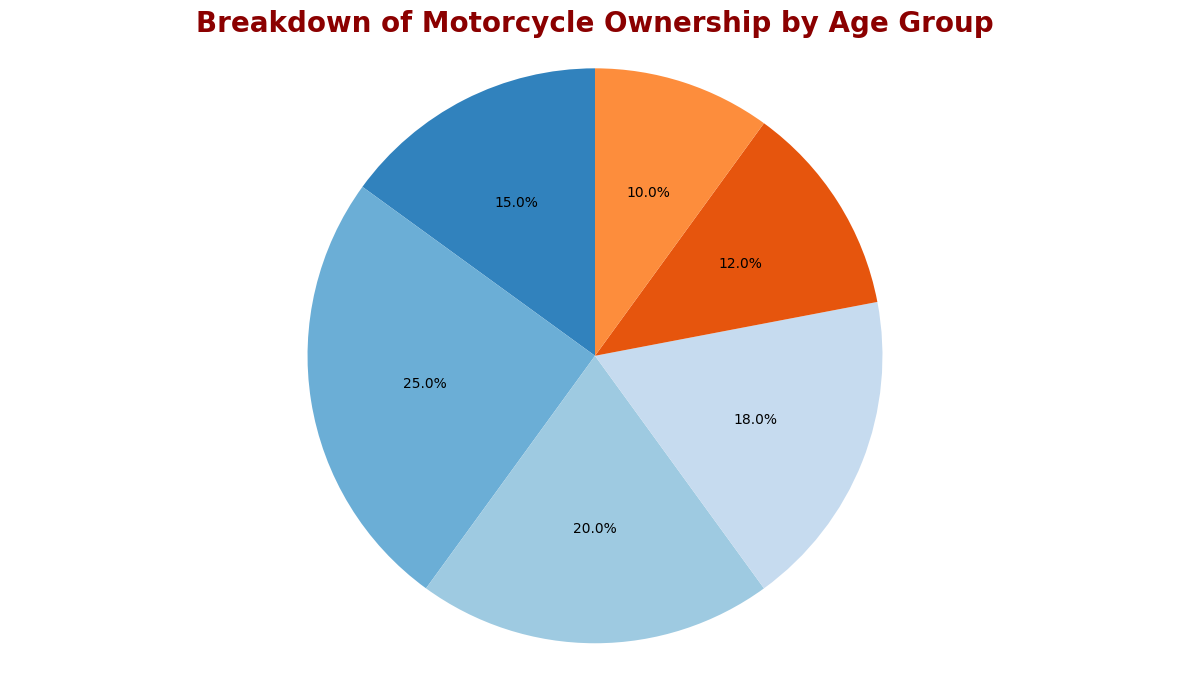Which age group has the highest percentage of motorcycle ownership? The figure shows that the 25-34 age group has the highest percentage of ownership at 25%.
Answer: 25-34 How much larger is the percentage of motorcycle ownership in the 25-34 age group compared to the 65+ age group? The 25-34 age group has 25% ownership and the 65+ age group has 10% ownership. The difference is calculated as 25%-10% = 15%.
Answer: 15% What is the combined percentage of motorcycle ownership for age groups 35-44 and 45-54? The percentage for the 35-44 age group is 20% and for the 45-54 age group is 18%. Adding them together results in 20% + 18% = 38%.
Answer: 38% Which age group has a slightly higher percentage of motorcycle ownership: 35-44 or 45-54? The figure shows that the 35-44 age group has 20% ownership, while the 45-54 age group has 18% ownership. 20% is slightly larger than 18%.
Answer: 35-44 What is the average percentage of motorcycle ownership for the three age groups with the lowest percentages? The age groups with the lowest percentages are 55-64 (12%), 65+ (10%), and 16-24 (15%). The average is calculated as (12% + 10% + 15%) / 3 = 12.33%.
Answer: 12.33% What fraction of the pie chart is represented by the 16-24 age group? The 16-24 age group represents 15% out of a total of 100%. Thus, the fraction is 15/100 = 3/20.
Answer: 3/20 Comparing 16-24 and 25-34 age groups, by what factor is the ownership percentage in the 25-34 age group larger? The 25-34 age group has 25% ownership, and the 16-24 age group has 15% ownership. The factor is calculated as 25% / 15% = 1.67.
Answer: 1.67 Which age group segment is visually the smallest on the pie chart? The figure shows that the 65+ age group has the smallest percentage of ownership at 10%, making it the visually smallest segment.
Answer: 65+ What is the cumulative percentage of motorcycle ownership for all age groups below 35 years? The relevant age groups are 16-24 (15%) and 25-34 (25%). Adding them together gives a cumulative percentage of 15% + 25% = 40%.
Answer: 40% If you combine the percentages of the 45-54 and 55-64 age groups, is the result larger than the percentage of the 25-34 age group? The 45-54 age group has 18%, and the 55-64 age group has 12%. Their combined percentage is 18% + 12% = 30%, which is smaller than the 25-34 age group's 25%.
Answer: No 